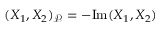Convert formula to latex. <formula><loc_0><loc_0><loc_500><loc_500>( X _ { 1 } , X _ { 2 } ) _ { \mathcal { P } } = - I m ( X _ { 1 } , X _ { 2 } )</formula> 